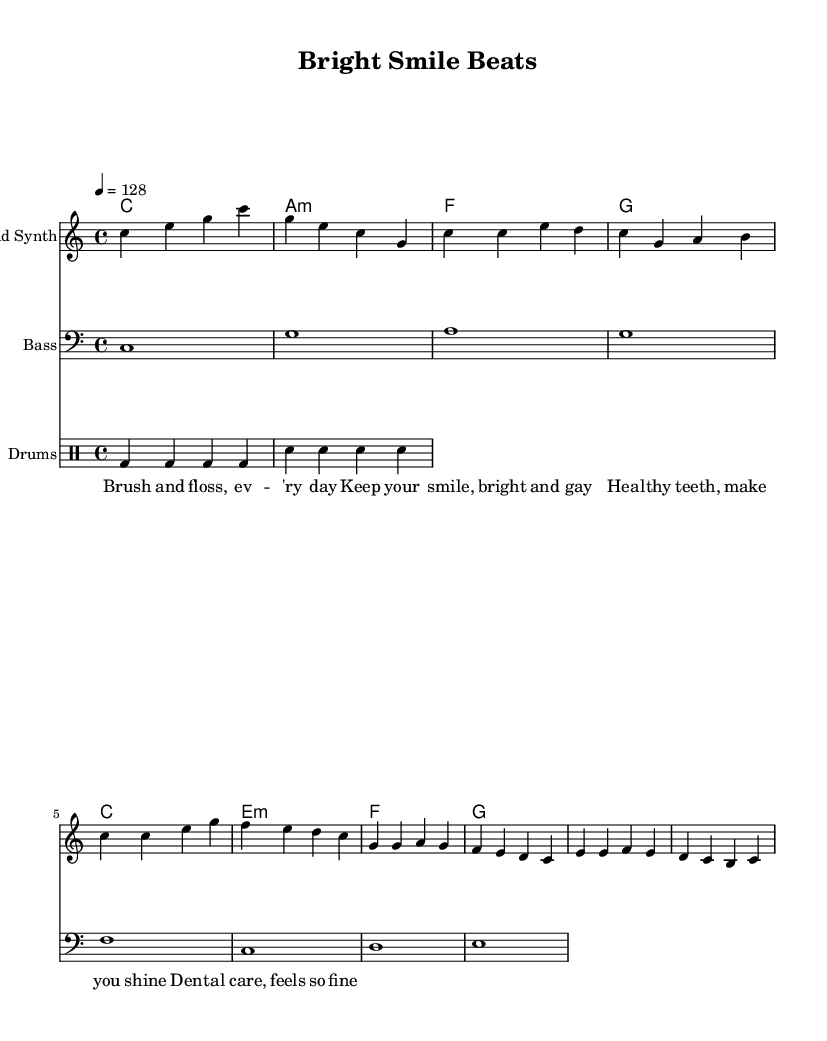What is the tempo of this music? The tempo marking in the score states "4 = 128", indicating that there are 128 beats per minute.
Answer: 128 What is the time signature of this piece? The time signature is indicated in the score as "4/4", which means there are four beats in each measure.
Answer: 4/4 How many measures are in the chorus section? The chorus consists of four measures based on the notes written after the "Chorus" label, and they contain distinct melodic lines.
Answer: 4 What is the key signature of this music? The key signature is C major, as indicated at the start of the score, which has no sharps or flats.
Answer: C major Which instrument plays the melody? The melody is played by the "Lead Synth," as specified in the staff details.
Answer: Lead Synth What are the lyrics of the first line? The lyrics for the first line are written beneath the notes and state, "Brush and floss, ev -- 'ry day."
Answer: Brush and floss, ev -- 'ry day What does the "Drummode" indicate in the score? The "Drummode" is used to indicate that the following notes represent a drum rhythm, showing the beat patterns for the drums in the piece.
Answer: Drum rhythm 